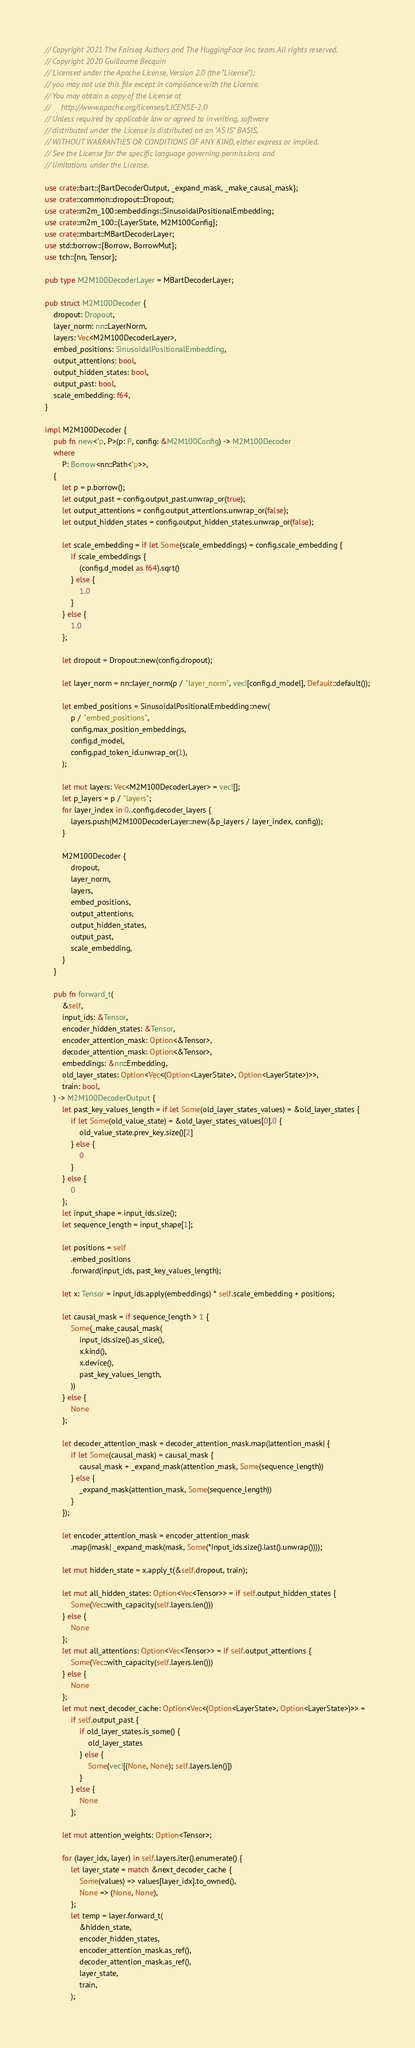Convert code to text. <code><loc_0><loc_0><loc_500><loc_500><_Rust_>// Copyright 2021 The Fairseq Authors and The HuggingFace Inc. team. All rights reserved.
// Copyright 2020 Guillaume Becquin
// Licensed under the Apache License, Version 2.0 (the "License");
// you may not use this file except in compliance with the License.
// You may obtain a copy of the License at
//     http://www.apache.org/licenses/LICENSE-2.0
// Unless required by applicable law or agreed to in writing, software
// distributed under the License is distributed on an "AS IS" BASIS,
// WITHOUT WARRANTIES OR CONDITIONS OF ANY KIND, either express or implied.
// See the License for the specific language governing permissions and
// limitations under the License.

use crate::bart::{BartDecoderOutput, _expand_mask, _make_causal_mask};
use crate::common::dropout::Dropout;
use crate::m2m_100::embeddings::SinusoidalPositionalEmbedding;
use crate::m2m_100::{LayerState, M2M100Config};
use crate::mbart::MBartDecoderLayer;
use std::borrow::{Borrow, BorrowMut};
use tch::{nn, Tensor};

pub type M2M100DecoderLayer = MBartDecoderLayer;

pub struct M2M100Decoder {
    dropout: Dropout,
    layer_norm: nn::LayerNorm,
    layers: Vec<M2M100DecoderLayer>,
    embed_positions: SinusoidalPositionalEmbedding,
    output_attentions: bool,
    output_hidden_states: bool,
    output_past: bool,
    scale_embedding: f64,
}

impl M2M100Decoder {
    pub fn new<'p, P>(p: P, config: &M2M100Config) -> M2M100Decoder
    where
        P: Borrow<nn::Path<'p>>,
    {
        let p = p.borrow();
        let output_past = config.output_past.unwrap_or(true);
        let output_attentions = config.output_attentions.unwrap_or(false);
        let output_hidden_states = config.output_hidden_states.unwrap_or(false);

        let scale_embedding = if let Some(scale_embeddings) = config.scale_embedding {
            if scale_embeddings {
                (config.d_model as f64).sqrt()
            } else {
                1.0
            }
        } else {
            1.0
        };

        let dropout = Dropout::new(config.dropout);

        let layer_norm = nn::layer_norm(p / "layer_norm", vec![config.d_model], Default::default());

        let embed_positions = SinusoidalPositionalEmbedding::new(
            p / "embed_positions",
            config.max_position_embeddings,
            config.d_model,
            config.pad_token_id.unwrap_or(1),
        );

        let mut layers: Vec<M2M100DecoderLayer> = vec![];
        let p_layers = p / "layers";
        for layer_index in 0..config.decoder_layers {
            layers.push(M2M100DecoderLayer::new(&p_layers / layer_index, config));
        }

        M2M100Decoder {
            dropout,
            layer_norm,
            layers,
            embed_positions,
            output_attentions,
            output_hidden_states,
            output_past,
            scale_embedding,
        }
    }

    pub fn forward_t(
        &self,
        input_ids: &Tensor,
        encoder_hidden_states: &Tensor,
        encoder_attention_mask: Option<&Tensor>,
        decoder_attention_mask: Option<&Tensor>,
        embeddings: &nn::Embedding,
        old_layer_states: Option<Vec<(Option<LayerState>, Option<LayerState>)>>,
        train: bool,
    ) -> M2M100DecoderOutput {
        let past_key_values_length = if let Some(old_layer_states_values) = &old_layer_states {
            if let Some(old_value_state) = &old_layer_states_values[0].0 {
                old_value_state.prev_key.size()[2]
            } else {
                0
            }
        } else {
            0
        };
        let input_shape = input_ids.size();
        let sequence_length = input_shape[1];

        let positions = self
            .embed_positions
            .forward(input_ids, past_key_values_length);

        let x: Tensor = input_ids.apply(embeddings) * self.scale_embedding + positions;

        let causal_mask = if sequence_length > 1 {
            Some(_make_causal_mask(
                input_ids.size().as_slice(),
                x.kind(),
                x.device(),
                past_key_values_length,
            ))
        } else {
            None
        };

        let decoder_attention_mask = decoder_attention_mask.map(|attention_mask| {
            if let Some(causal_mask) = causal_mask {
                causal_mask + _expand_mask(attention_mask, Some(sequence_length))
            } else {
                _expand_mask(attention_mask, Some(sequence_length))
            }
        });

        let encoder_attention_mask = encoder_attention_mask
            .map(|mask| _expand_mask(mask, Some(*input_ids.size().last().unwrap())));

        let mut hidden_state = x.apply_t(&self.dropout, train);

        let mut all_hidden_states: Option<Vec<Tensor>> = if self.output_hidden_states {
            Some(Vec::with_capacity(self.layers.len()))
        } else {
            None
        };
        let mut all_attentions: Option<Vec<Tensor>> = if self.output_attentions {
            Some(Vec::with_capacity(self.layers.len()))
        } else {
            None
        };
        let mut next_decoder_cache: Option<Vec<(Option<LayerState>, Option<LayerState>)>> =
            if self.output_past {
                if old_layer_states.is_some() {
                    old_layer_states
                } else {
                    Some(vec![(None, None); self.layers.len()])
                }
            } else {
                None
            };

        let mut attention_weights: Option<Tensor>;

        for (layer_idx, layer) in self.layers.iter().enumerate() {
            let layer_state = match &next_decoder_cache {
                Some(values) => values[layer_idx].to_owned(),
                None => (None, None),
            };
            let temp = layer.forward_t(
                &hidden_state,
                encoder_hidden_states,
                encoder_attention_mask.as_ref(),
                decoder_attention_mask.as_ref(),
                layer_state,
                train,
            );</code> 